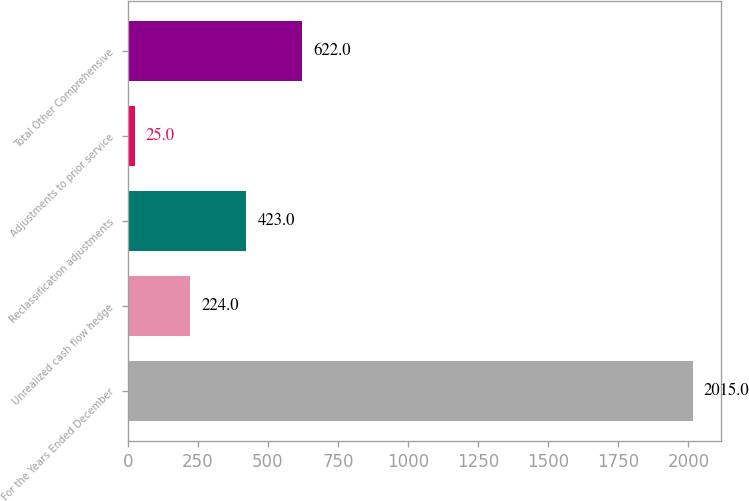<chart> <loc_0><loc_0><loc_500><loc_500><bar_chart><fcel>For the Years Ended December<fcel>Unrealized cash flow hedge<fcel>Reclassification adjustments<fcel>Adjustments to prior service<fcel>Total Other Comprehensive<nl><fcel>2015<fcel>224<fcel>423<fcel>25<fcel>622<nl></chart> 